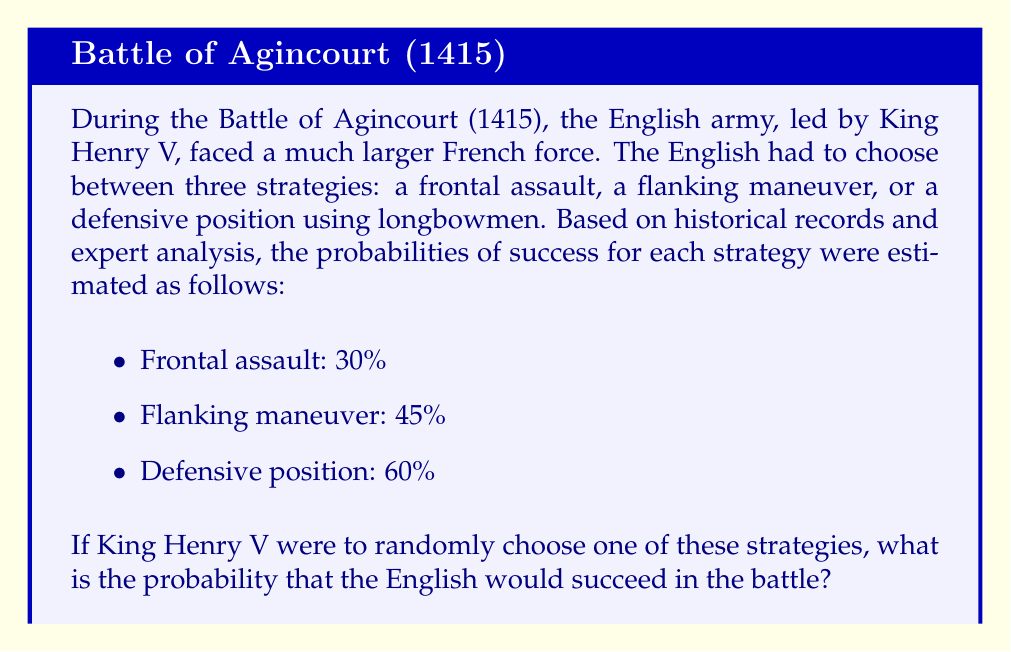What is the answer to this math problem? To solve this problem, we need to apply the concept of expected value from probability theory. Since the strategy is chosen randomly, each strategy has an equal probability of being selected, which is $\frac{1}{3}$.

Let's calculate the probability of success:

1. Define the event S as "success in the battle".
2. Define the events A, B, and C as choosing the frontal assault, flanking maneuver, and defensive position strategies, respectively.

We can use the law of total probability:

$$P(S) = P(S|A) \cdot P(A) + P(S|B) \cdot P(B) + P(S|C) \cdot P(C)$$

Where:
- $P(S|A)$ is the probability of success given strategy A is chosen (30% or 0.30)
- $P(S|B)$ is the probability of success given strategy B is chosen (45% or 0.45)
- $P(S|C)$ is the probability of success given strategy C is chosen (60% or 0.60)
- $P(A) = P(B) = P(C) = \frac{1}{3}$ (equal probability of choosing each strategy)

Now, let's substitute these values:

$$P(S) = 0.30 \cdot \frac{1}{3} + 0.45 \cdot \frac{1}{3} + 0.60 \cdot \frac{1}{3}$$

$$P(S) = \frac{0.30 + 0.45 + 0.60}{3}$$

$$P(S) = \frac{1.35}{3} = 0.45$$

Therefore, the probability of success if King Henry V were to randomly choose one of these strategies is 0.45 or 45%.
Answer: 0.45 or 45% 